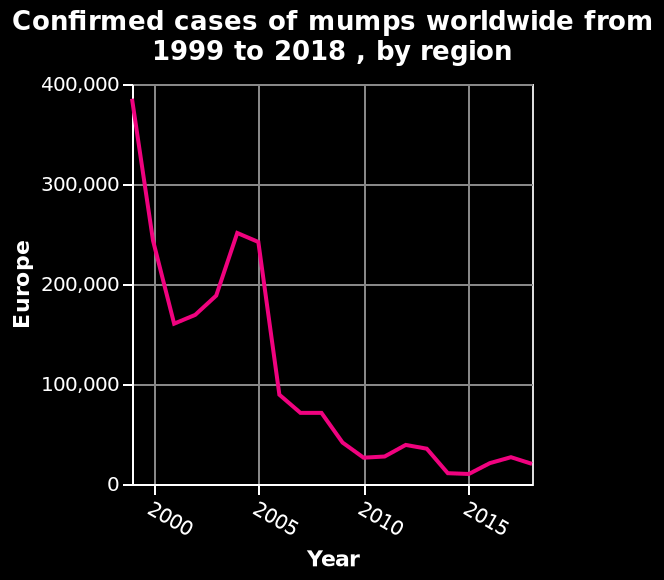<image>
What is the current number of cases? The current number of cases is less than 100,000. What is the range of years represented on the x-axis in the line plot? The range of years represented on the x-axis in the line plot is from 2000 to 2015. What is the percentage decrease in the number of cases? The percentage decrease in the number of cases is around 75%. What is the minimum value on the y-axis in the line plot? The minimum value on the y-axis in the line plot is 0. Which region does the line plot represent? The line plot represents the region of Europe. 